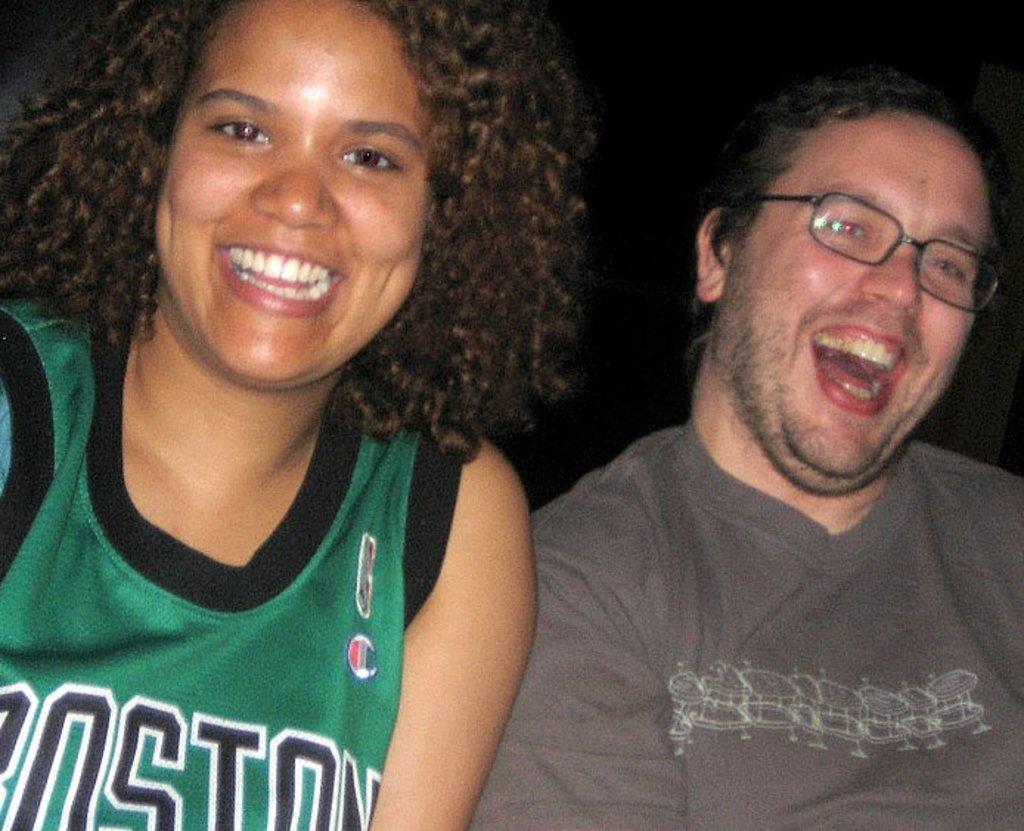Can you describe this image briefly? In this picture, we see a woman and a man are smiling and they are posing for the photo. The man on the right side is wearing the spectacles. In the background, it is black in color. This picture might be clicked in the dark. 